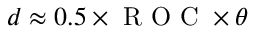Convert formula to latex. <formula><loc_0><loc_0><loc_500><loc_500>d \approx 0 . 5 \times R O C \times \theta</formula> 